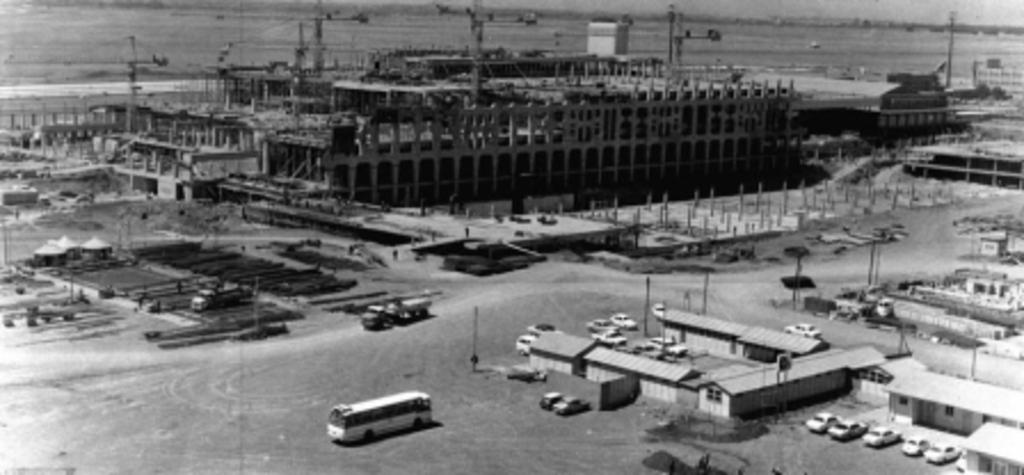What is the color scheme of the image? The image is black and white. What can be seen in the image besides the color scheme? There are many buildings, vehicles, and poles in the image. What activity is taking place in the image? The construction of a building is visible in the image. How would you describe the background of the image? The background appears blurry. What type of mark can be seen on the cord in the image? There is no cord present in the image, so it is not possible to determine if there is a mark on it. What time of day is depicted in the image? The image does not provide any information about the time of day, as it is in black and white and does not include any time-specific details. 